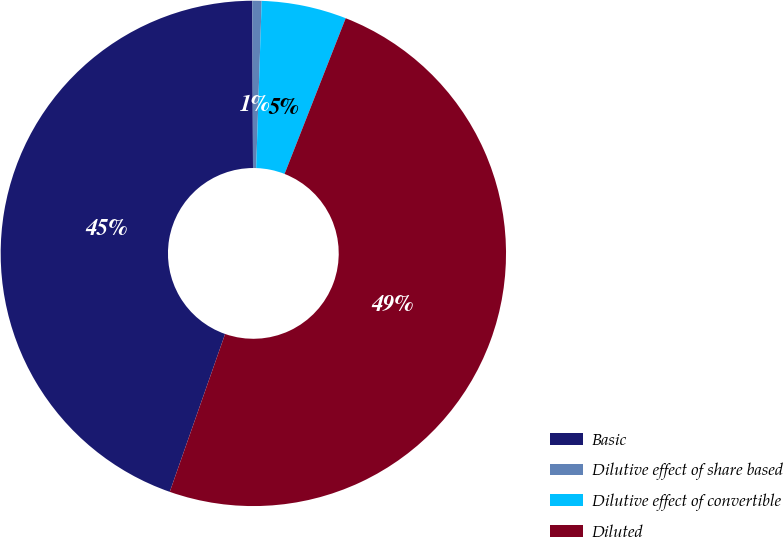<chart> <loc_0><loc_0><loc_500><loc_500><pie_chart><fcel>Basic<fcel>Dilutive effect of share based<fcel>Dilutive effect of convertible<fcel>Diluted<nl><fcel>44.57%<fcel>0.59%<fcel>5.43%<fcel>49.41%<nl></chart> 